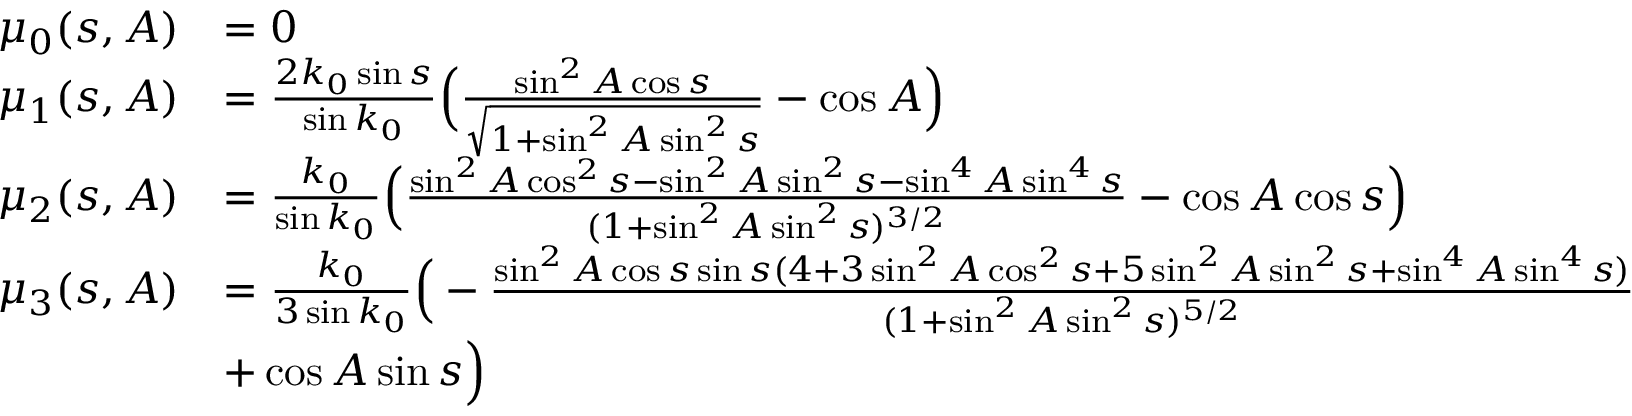<formula> <loc_0><loc_0><loc_500><loc_500>\begin{array} { r l } { \mu _ { 0 } ( s , A ) } & { = 0 } \\ { \mu _ { 1 } ( s , A ) } & { = \frac { 2 k _ { 0 } \sin s } { \sin k _ { 0 } } \left ( \frac { \sin ^ { 2 } A \cos s } { \sqrt { 1 + \sin ^ { 2 } A \sin ^ { 2 } s } } - \cos A \right ) } \\ { \mu _ { 2 } ( s , A ) } & { = \frac { k _ { 0 } } { \sin k _ { 0 } } \left ( \frac { \sin ^ { 2 } A \cos ^ { 2 } s - \sin ^ { 2 } A \sin ^ { 2 } s - \sin ^ { 4 } A \sin ^ { 4 } s } { ( 1 + \sin ^ { 2 } A \sin ^ { 2 } s ) ^ { 3 / 2 } } - \cos A \cos s \right ) } \\ { \mu _ { 3 } ( s , A ) } & { = \frac { k _ { 0 } } { 3 \sin k _ { 0 } } \left ( - \frac { \sin ^ { 2 } A \cos s \sin s ( 4 + 3 \sin ^ { 2 } A \cos ^ { 2 } s + 5 \sin ^ { 2 } A \sin ^ { 2 } s + \sin ^ { 4 } A \sin ^ { 4 } s ) } { ( 1 + \sin ^ { 2 } A \sin ^ { 2 } s ) ^ { 5 / 2 } } } \\ & { + \cos A \sin s \right ) } \end{array}</formula> 